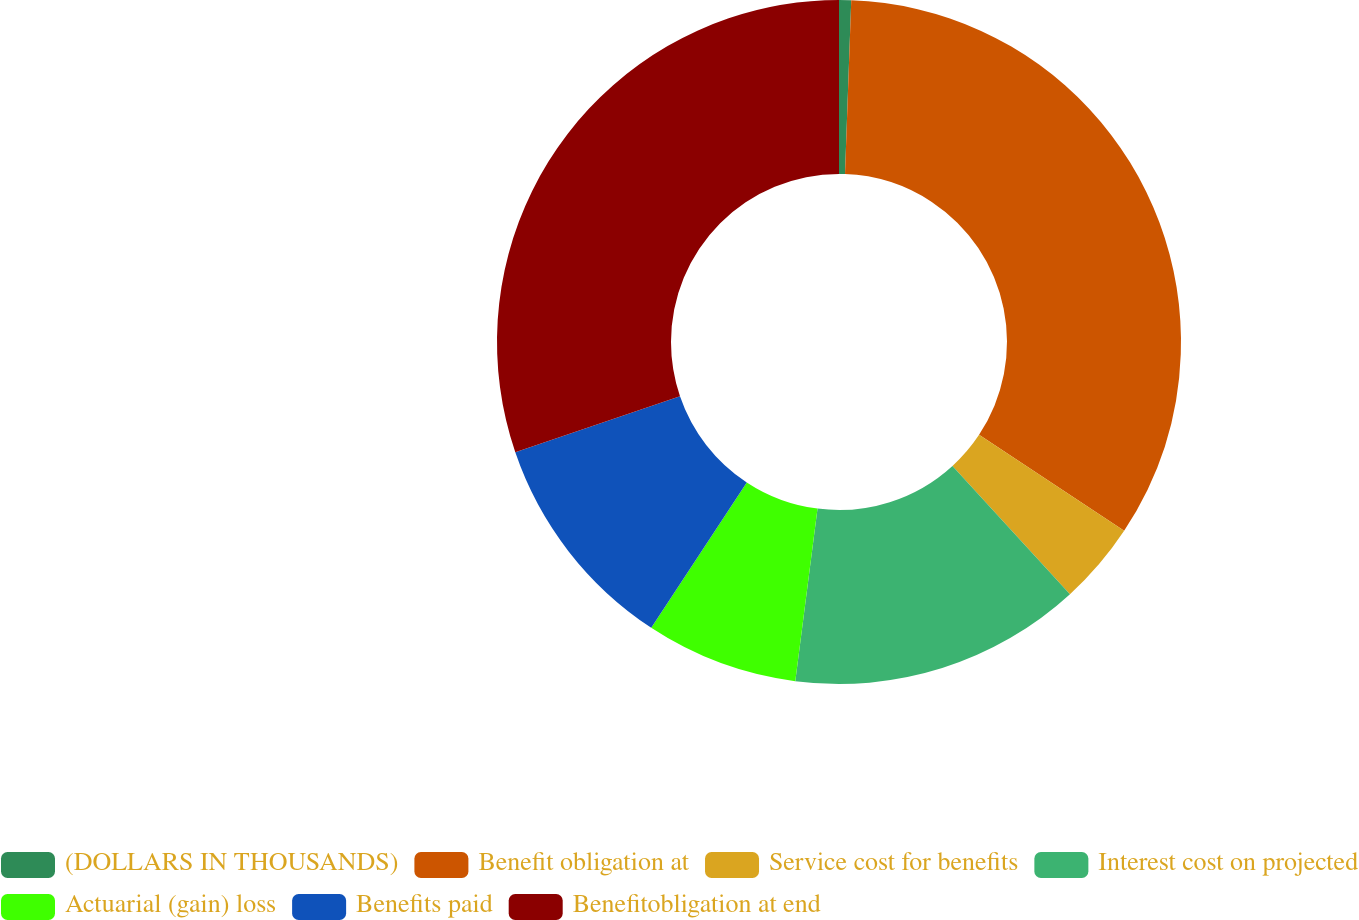<chart> <loc_0><loc_0><loc_500><loc_500><pie_chart><fcel>(DOLLARS IN THOUSANDS)<fcel>Benefit obligation at<fcel>Service cost for benefits<fcel>Interest cost on projected<fcel>Actuarial (gain) loss<fcel>Benefits paid<fcel>Benefitobligation at end<nl><fcel>0.57%<fcel>33.74%<fcel>3.89%<fcel>13.84%<fcel>7.21%<fcel>10.52%<fcel>30.23%<nl></chart> 